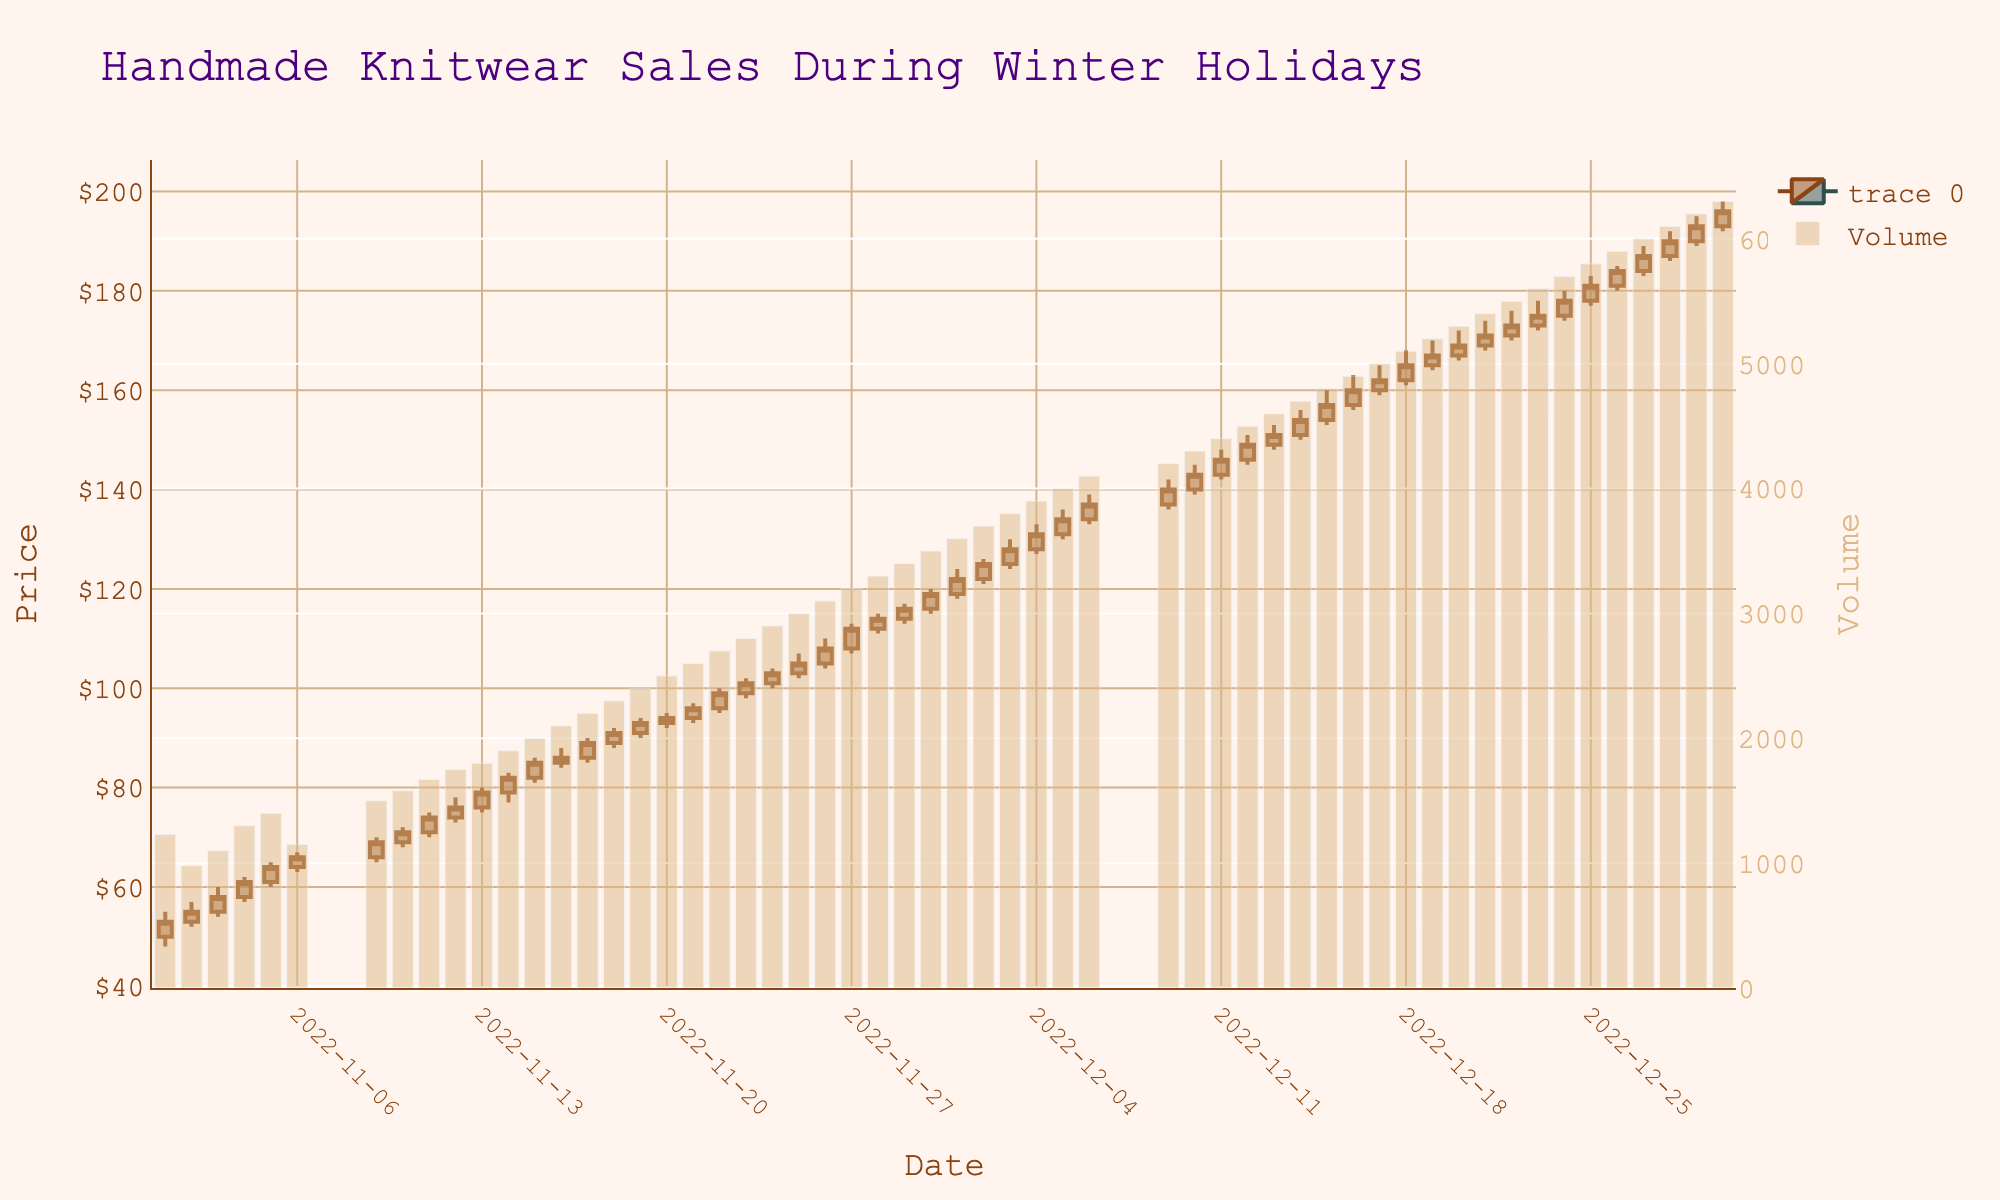How does the price change from December 1 to December 2? To find the price change, subtract the closing price on December 1 ($122) from the closing price on December 2 ($125). The change is 125 - 122.
Answer: $3 What is the highest price observed in the data? Looking at the 'High' values in the data, the highest recorded price is on December 18, which is $168.
Answer: $168 Which date shows the highest trading volume, and what is the volume? The highest trading volume is observed on December 30, with a volume of 6300.
Answer: December 30, 6300 Compare the opening prices of November 5 and December 5. Which date has a higher opening price, and by how much? The opening price on November 5 is 61, and on December 5 it is 131. December 5 has a higher opening price by 131 - 61 = 70.
Answer: December 5, $70 What is the volume trend from November 20 to November 22? From November 20 to November 22, the volumes are 2500, 2600, and 2700 respectively. The trend shows a gradual increase each day by 100.
Answer: Increasing What colors are used to indicate increasing and decreasing prices in the candlestick plot? The increasing prices are indicated with SaddleBrown, and the decreasing prices are indicated with DarkSlateGray.
Answer: SaddleBrown and DarkSlateGray Determine the lowest closing price and the corresponding date. The lowest closing price is on November 2 and it is $55.
Answer: $55, November 2 How many days show a closing price greater than the opening price? Each candlestick where the closing price is higher than the opening price is confirmed by counting directly. This occurs 18 times based on the data provided.
Answer: 18 Days What was the opening price on December 25, and how does it compare to the opening price on December 1? The opening price on December 25 is 178, whereas on December 1 it is 119. The difference is 178 - 119 = 59.
Answer: $59 higher What general trend can be observed in the volume of trades as winter holidays approach? Observing the volume increases consistently from beginning to the end of December, indicating a rising trend as winter holidays approach.
Answer: Increasing Trend 